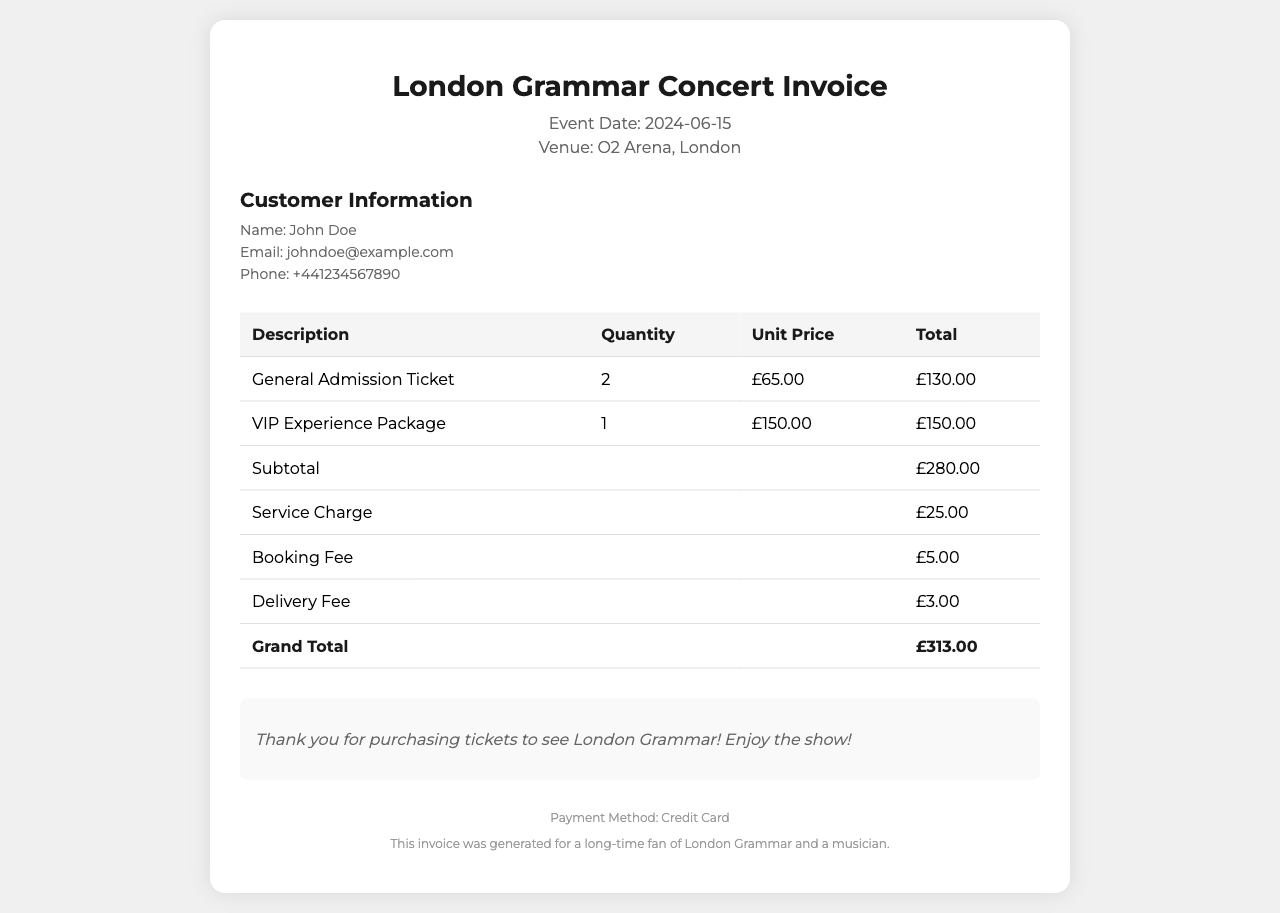What is the event date? The event date is specified in the header section of the document as June 15, 2024.
Answer: June 15, 2024 What is the venue for the concert? The venue is mentioned in the header section, indicating where the event will take place, which is O2 Arena, London.
Answer: O2 Arena, London How many general admission tickets were purchased? The number of general admission tickets is stated in the document as 2.
Answer: 2 What is the total price for the VIP Experience Package? The total price for the VIP Experience Package is found in the table, specifically listed as £150.00.
Answer: £150.00 What is the subtotal amount before additional fees? The subtotal can be found in the table, which summarizes the cost of tickets before fees, stated as £280.00.
Answer: £280.00 What is the total service charge? The service charge is broken down in the document and specifically stated as £25.00.
Answer: £25.00 What is the grand total for the invoice? The grand total is the final amount calculated at the bottom of the table, which is £313.00.
Answer: £313.00 Who is the customer listed on the invoice? The customer's name is provided in the customer details section of the document as John Doe.
Answer: John Doe What payment method was used for the tickets? The payment method is mentioned in the footer of the document as a credit card.
Answer: Credit Card 